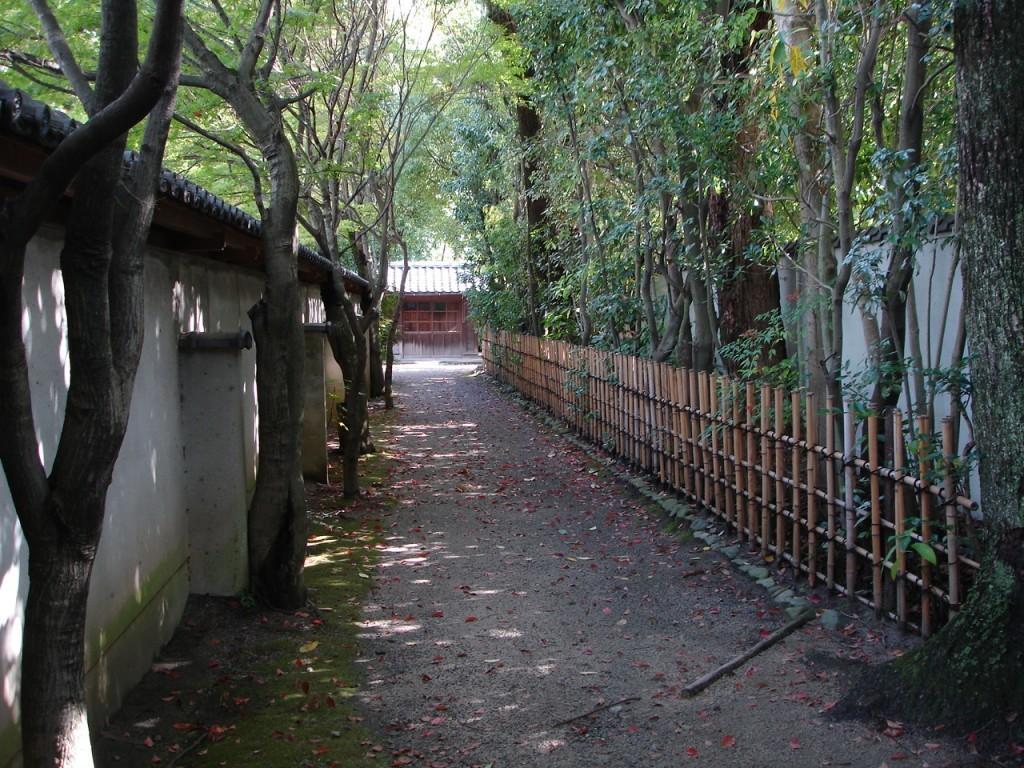Please provide a concise description of this image. In this image we can see a group of trees. On the right side, we can see a wooden fence and a wall. On the left side, we can see a wall of a house. In the background, we can see a house. In the foreground there are many dried leaves on the ground. At the top we can see the sky. 